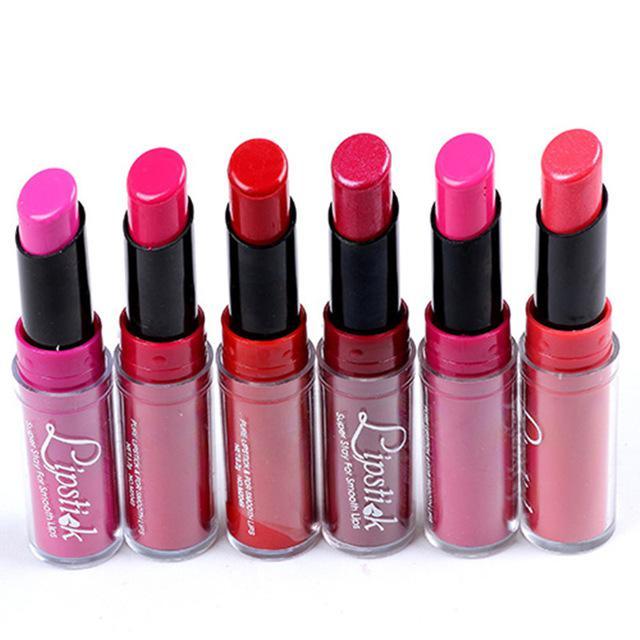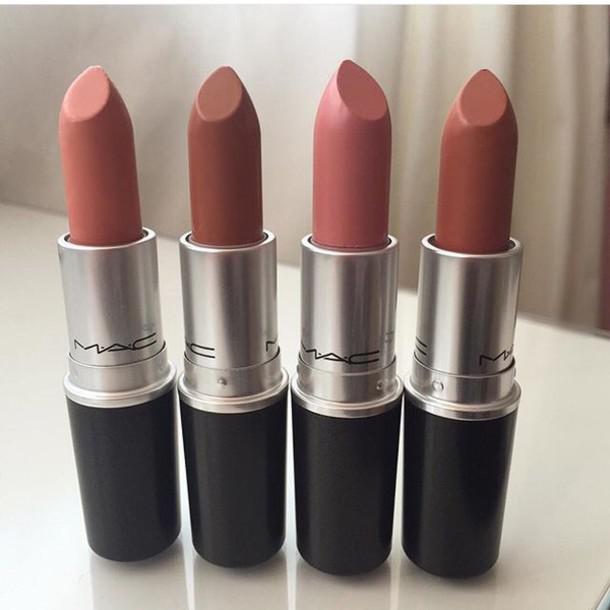The first image is the image on the left, the second image is the image on the right. For the images displayed, is the sentence "The image to the left contains exactly 6 lipsticks." factually correct? Answer yes or no. Yes. 